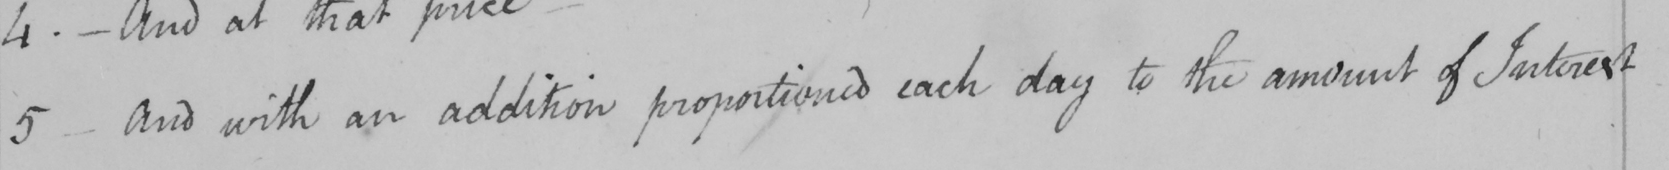Transcribe the text shown in this historical manuscript line. 5 . _  And with an addition proportioned each day to the amount of Interest 